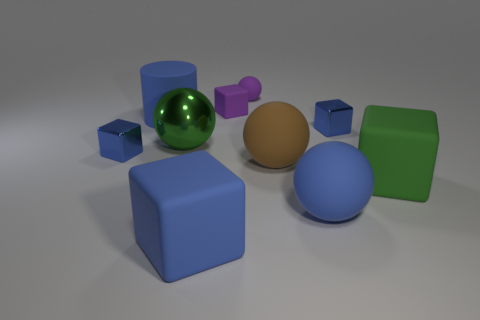Subtract all blue blocks. How many were subtracted if there are1blue blocks left? 2 Subtract all large blue balls. How many balls are left? 3 Subtract 3 balls. How many balls are left? 1 Subtract all blue spheres. How many spheres are left? 3 Subtract all big cylinders. Subtract all purple rubber balls. How many objects are left? 8 Add 8 green matte objects. How many green matte objects are left? 9 Add 2 large purple metal spheres. How many large purple metal spheres exist? 2 Subtract 0 yellow spheres. How many objects are left? 10 Subtract all balls. How many objects are left? 6 Subtract all cyan blocks. Subtract all yellow spheres. How many blocks are left? 5 